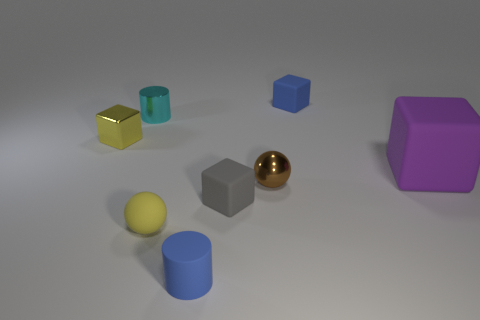Subtract 1 blocks. How many blocks are left? 3 Subtract all green balls. Subtract all blue cylinders. How many balls are left? 2 Add 1 metallic spheres. How many objects exist? 9 Subtract all balls. How many objects are left? 6 Subtract all tiny cyan cylinders. Subtract all large purple blocks. How many objects are left? 6 Add 3 brown objects. How many brown objects are left? 4 Add 6 blue cylinders. How many blue cylinders exist? 7 Subtract 1 gray cubes. How many objects are left? 7 